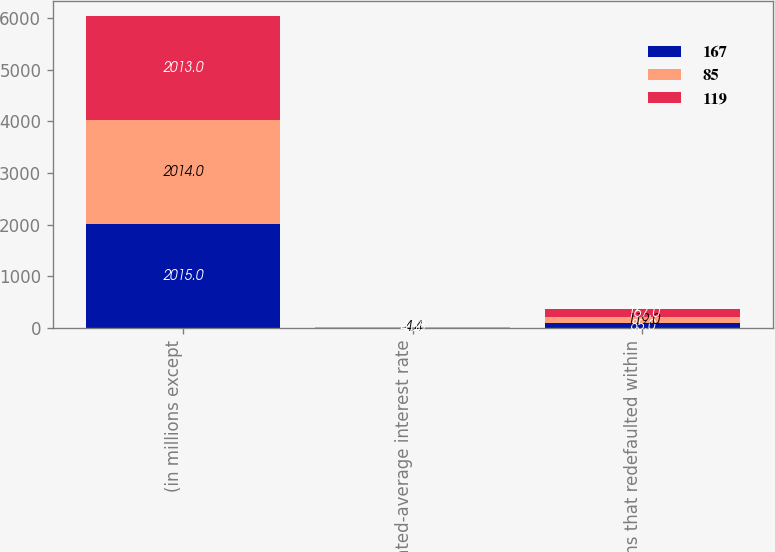Convert chart. <chart><loc_0><loc_0><loc_500><loc_500><stacked_bar_chart><ecel><fcel>(in millions except<fcel>Weighted-average interest rate<fcel>Loans that redefaulted within<nl><fcel>167<fcel>2015<fcel>4.4<fcel>85<nl><fcel>85<fcel>2014<fcel>4.4<fcel>119<nl><fcel>119<fcel>2013<fcel>4.38<fcel>167<nl></chart> 